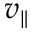Convert formula to latex. <formula><loc_0><loc_0><loc_500><loc_500>v _ { \| }</formula> 